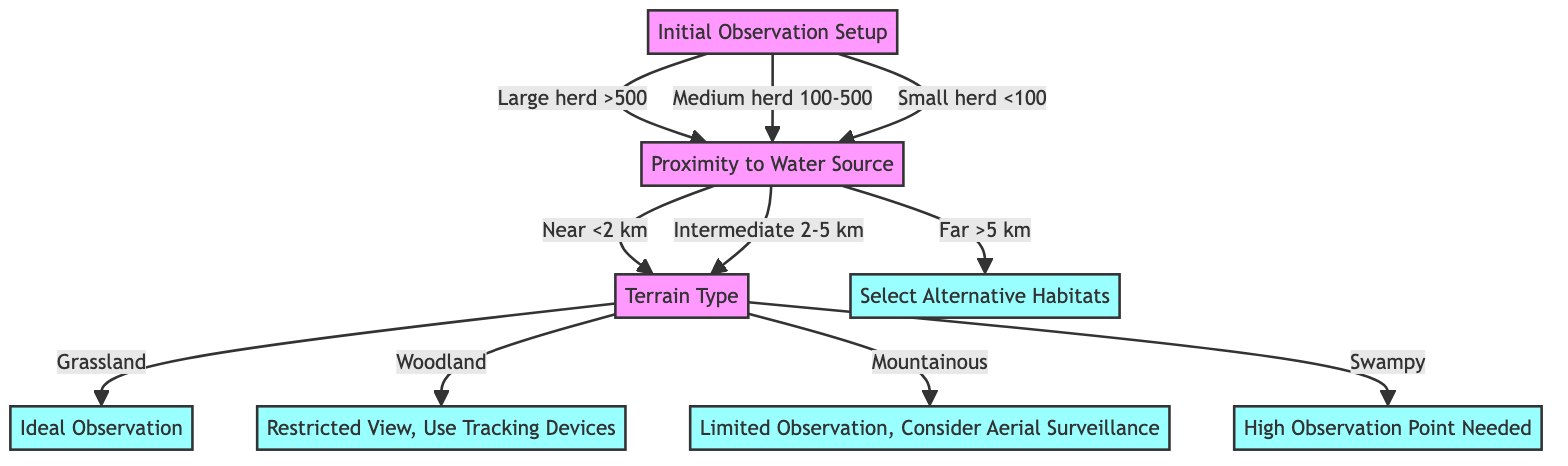What is the first question asked in the decision tree? The top node in the decision tree is "Initial Observation Setup," and the first question it poses is "What is the herd size?"
Answer: What is the herd size? How many options are there under "Proximity to Water Source"? The "Proximity to Water Source" node has three options: Near (<2 km), Intermediate (2-5 km), and Far (>5 km), making a total of three options.
Answer: Three What action is taken if the herd is far from the water source? In the case where the herd is far from the water source (>5 km), the action is to "Select Alternative Habitats" as indicated in the diagram.
Answer: Select Alternative Habitats What happens if the terrain type is grassland? According to the diagram, if the terrain type is grassland, the action recommended is "Ideal Observation." This is directly mentioned in the outcome of the decision tree.
Answer: Ideal Observation If the herd size is medium and the water source is near, what is the next step? Starting from a medium herd size (100-500), it leads to the next node asking about proximity to the water source. Since the water source is near (<2 km), it then leads to the "Terrain Type" node, where the next question is about the terrain type.
Answer: Terrain Type What is the outcome if the terrain type is woodland? If the terrain type is woodland, the diagram specifies the action to be "Restricted View, Use Tracking Devices." This outcome is clearly defined for that specific option within the diagram.
Answer: Restricted View, Use Tracking Devices How does the decision tree branch if the herd size is small? If the herd size is small (<100), similar to the medium and large herds, it still branches directly to "Proximity to Water Source." This shows that herd size doesn't affect the branching at this stage.
Answer: Proximity to Water Source What relationship exists between "Proximity to Water Source" and "Terrain Type"? The relationship is that "Proximity to Water Source" serves as a prerequisite that leads to "Terrain Type" based on whether the herd is near or far from the water source. Thus, the proximity determines if the next question about terrain type is asked.
Answer: Proximity determines next question 